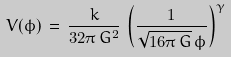<formula> <loc_0><loc_0><loc_500><loc_500>V ( \phi ) \, = \, \frac { k } { 3 2 \pi \, G ^ { 2 } } \, \left ( \frac { 1 } { { \sqrt { 1 6 \pi \, G } } \, \phi } \right ) ^ { \gamma }</formula> 